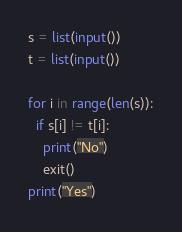<code> <loc_0><loc_0><loc_500><loc_500><_Python_>s = list(input())
t = list(input())

for i in range(len(s)):
  if s[i] != t[i]:
    print("No")
    exit()
print("Yes")</code> 